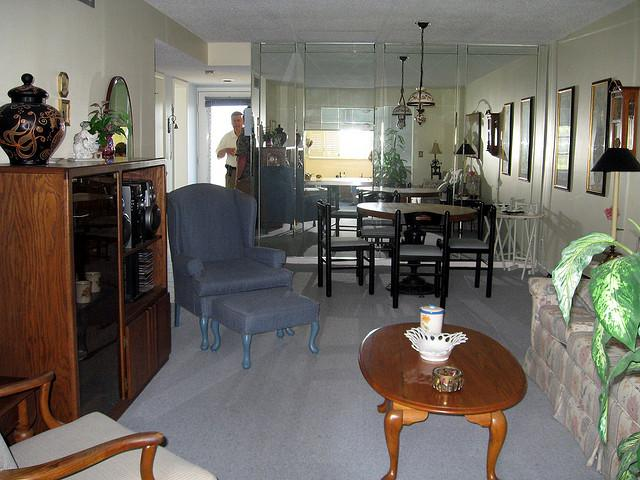What color is the vase in the middle of the coffee table?

Choices:
A) white
B) red
C) green
D) gold white 